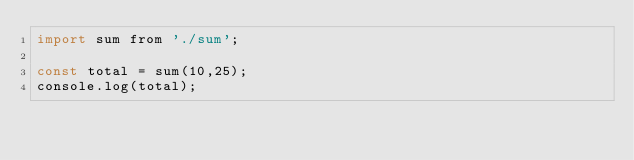Convert code to text. <code><loc_0><loc_0><loc_500><loc_500><_JavaScript_>import sum from './sum';

const total = sum(10,25);
console.log(total);</code> 